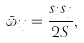Convert formula to latex. <formula><loc_0><loc_0><loc_500><loc_500>\bar { \omega } _ { i j } = \frac { s _ { i } s _ { j } } { 2 S } ,</formula> 